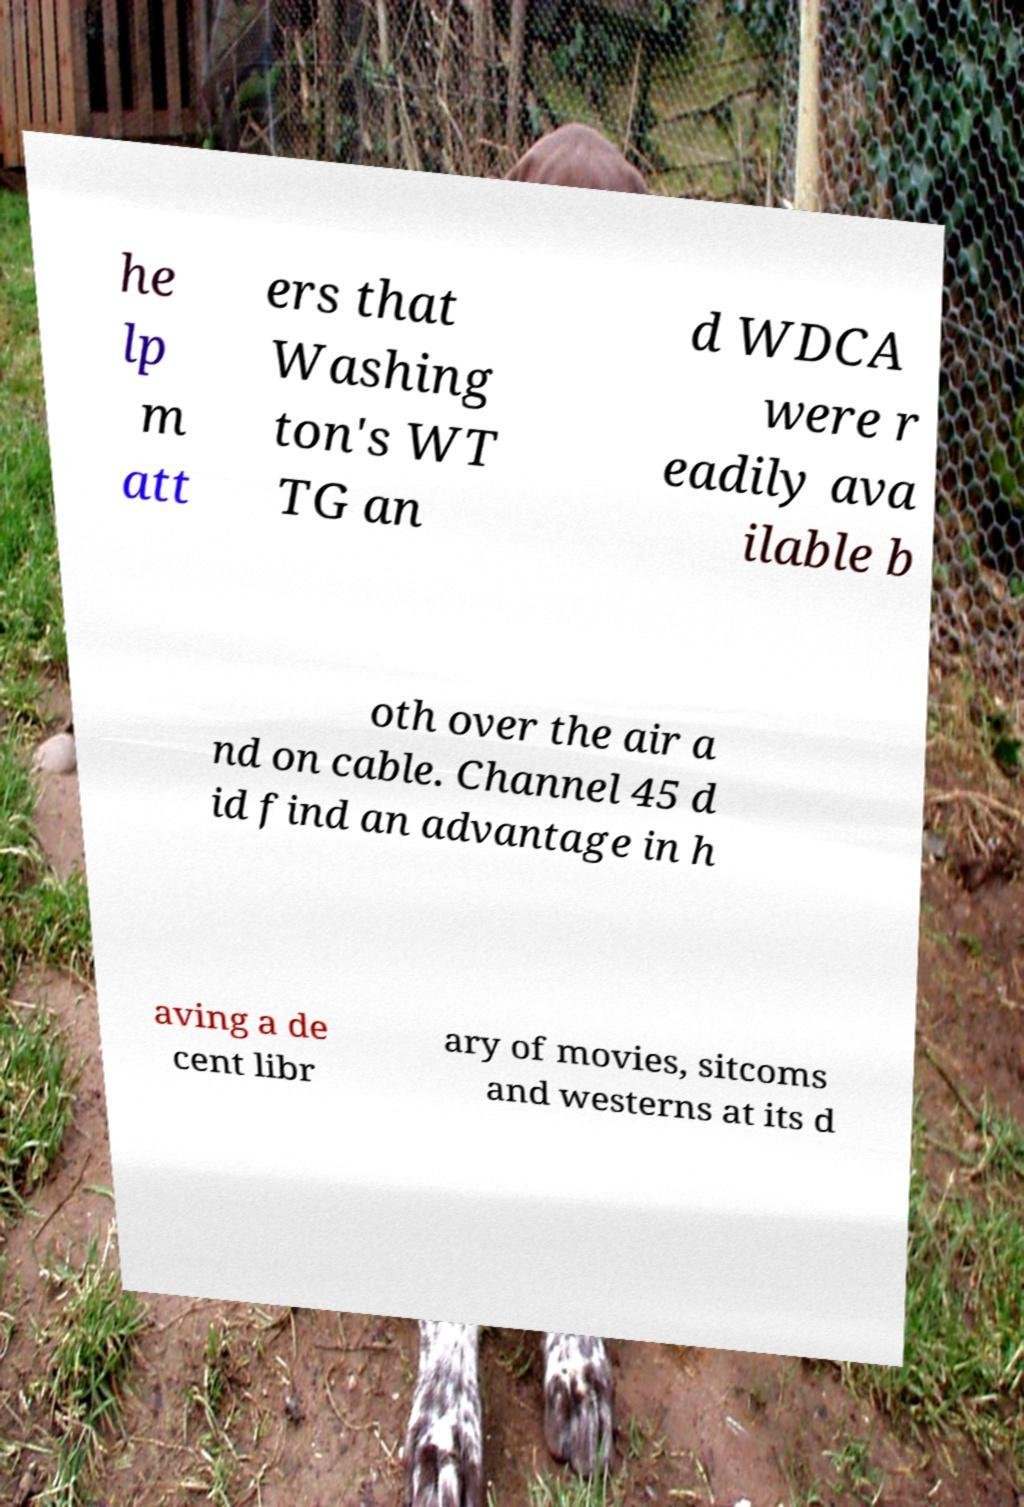Can you accurately transcribe the text from the provided image for me? he lp m att ers that Washing ton's WT TG an d WDCA were r eadily ava ilable b oth over the air a nd on cable. Channel 45 d id find an advantage in h aving a de cent libr ary of movies, sitcoms and westerns at its d 